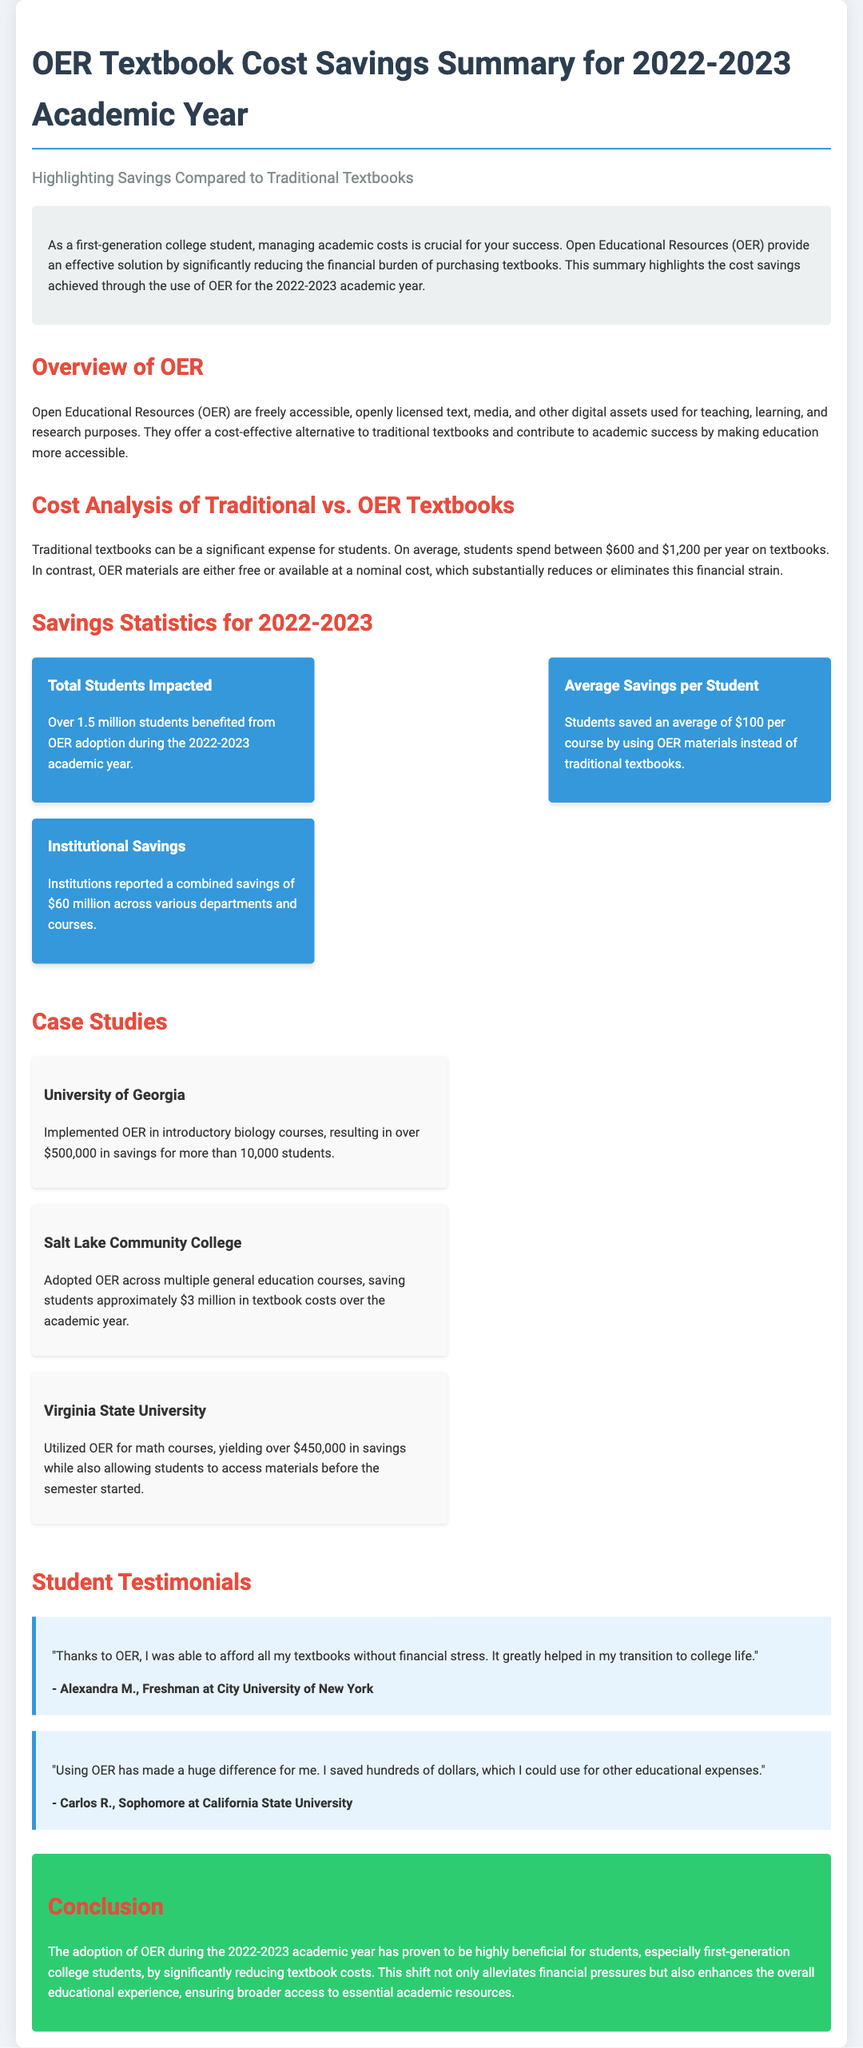What is the total number of students impacted by OER? Over 1.5 million students benefited from OER adoption during the 2022-2023 academic year.
Answer: Over 1.5 million What is the average savings per student when using OER? Students saved an average of $100 per course by using OER materials instead of traditional textbooks.
Answer: $100 What was the total institutional savings reported? Institutions reported a combined savings of $60 million across various departments and courses.
Answer: $60 million Which university saved over $500,000 with OER? Implemented OER in introductory biology courses, resulting in over $500,000 in savings for more than 10,000 students.
Answer: University of Georgia What is the main benefit of OER according to the conclusion? This shift not only alleviates financial pressures but also enhances the overall educational experience.
Answer: Enhances educational experience Why do first-generation college students rely on OER? Managing academic costs is crucial for their success.
Answer: Academic cost management 